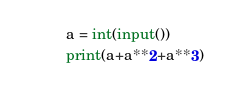Convert code to text. <code><loc_0><loc_0><loc_500><loc_500><_Python_>a = int(input())
print(a+a**2+a**3)</code> 